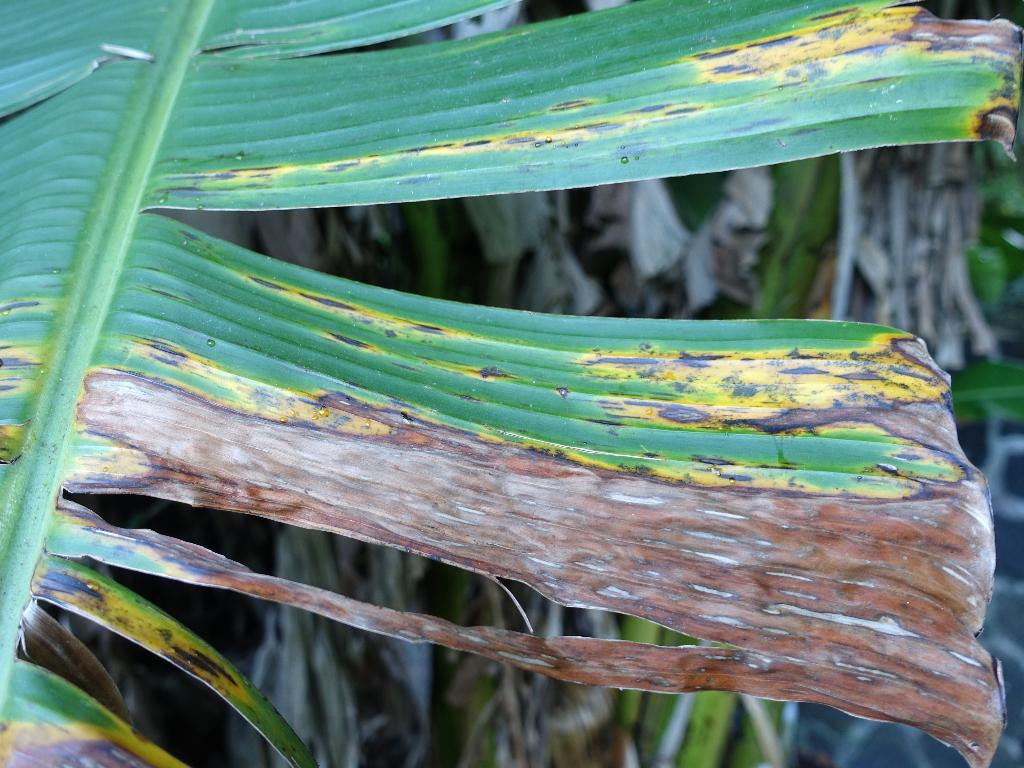What is the main subject of the image? The main subject of the image is a diseased leaf. How is the background of the image depicted? The background of the image is blurred. What else can be seen in the image besides the diseased leaf? There are plants visible in the background of the image. What type of brass instrument is being played in the background of the image? There is no brass instrument present in the image; it features a diseased leaf and blurred plants in the background. 